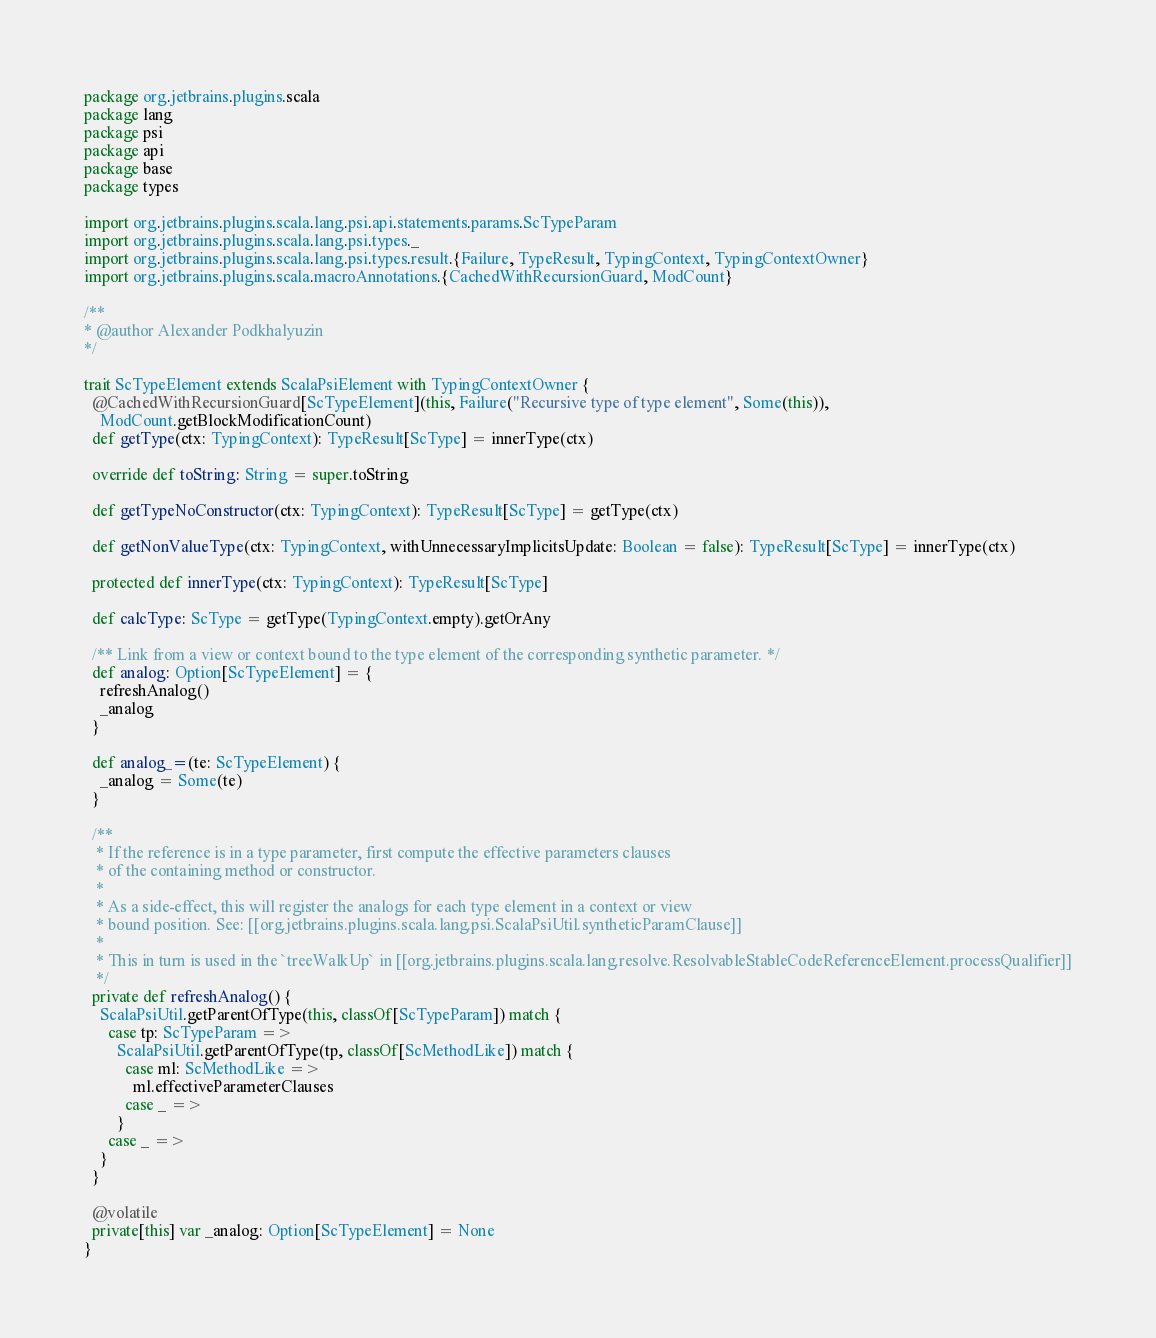<code> <loc_0><loc_0><loc_500><loc_500><_Scala_>package org.jetbrains.plugins.scala
package lang
package psi
package api
package base
package types

import org.jetbrains.plugins.scala.lang.psi.api.statements.params.ScTypeParam
import org.jetbrains.plugins.scala.lang.psi.types._
import org.jetbrains.plugins.scala.lang.psi.types.result.{Failure, TypeResult, TypingContext, TypingContextOwner}
import org.jetbrains.plugins.scala.macroAnnotations.{CachedWithRecursionGuard, ModCount}

/**
* @author Alexander Podkhalyuzin
*/

trait ScTypeElement extends ScalaPsiElement with TypingContextOwner {
  @CachedWithRecursionGuard[ScTypeElement](this, Failure("Recursive type of type element", Some(this)),
    ModCount.getBlockModificationCount)
  def getType(ctx: TypingContext): TypeResult[ScType] = innerType(ctx)

  override def toString: String = super.toString

  def getTypeNoConstructor(ctx: TypingContext): TypeResult[ScType] = getType(ctx)

  def getNonValueType(ctx: TypingContext, withUnnecessaryImplicitsUpdate: Boolean = false): TypeResult[ScType] = innerType(ctx)

  protected def innerType(ctx: TypingContext): TypeResult[ScType]

  def calcType: ScType = getType(TypingContext.empty).getOrAny

  /** Link from a view or context bound to the type element of the corresponding synthetic parameter. */
  def analog: Option[ScTypeElement] = {
    refreshAnalog()
    _analog
  }

  def analog_=(te: ScTypeElement) {
    _analog = Some(te)
  }

  /**
   * If the reference is in a type parameter, first compute the effective parameters clauses
   * of the containing method or constructor.
   *
   * As a side-effect, this will register the analogs for each type element in a context or view
   * bound position. See: [[org.jetbrains.plugins.scala.lang.psi.ScalaPsiUtil.syntheticParamClause]]
   *
   * This in turn is used in the `treeWalkUp` in [[org.jetbrains.plugins.scala.lang.resolve.ResolvableStableCodeReferenceElement.processQualifier]]
   */
  private def refreshAnalog() {
    ScalaPsiUtil.getParentOfType(this, classOf[ScTypeParam]) match {
      case tp: ScTypeParam =>
        ScalaPsiUtil.getParentOfType(tp, classOf[ScMethodLike]) match {
          case ml: ScMethodLike =>
            ml.effectiveParameterClauses
          case _ =>
        }
      case _ =>
    }
  }

  @volatile
  private[this] var _analog: Option[ScTypeElement] = None
}
</code> 